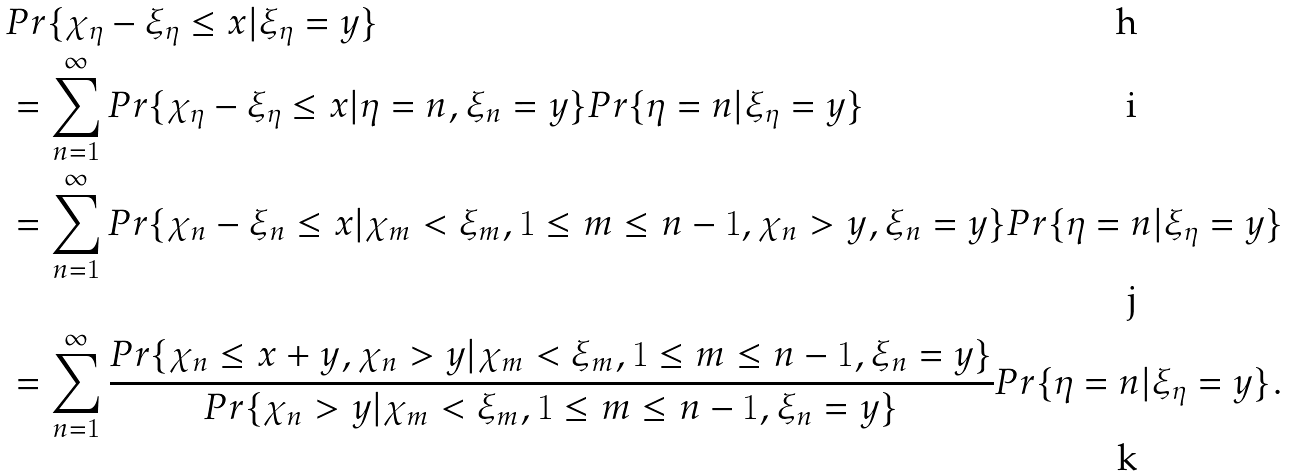<formula> <loc_0><loc_0><loc_500><loc_500>& P r \{ \chi _ { \eta } - \xi _ { \eta } \leq x | \xi _ { \eta } = y \} \\ & = \sum _ { n = 1 } ^ { \infty } P r \{ \chi _ { \eta } - \xi _ { \eta } \leq x | \eta = n , \xi _ { n } = y \} P r \{ \eta = n | \xi _ { \eta } = y \} \\ & = \sum _ { n = 1 } ^ { \infty } P r \{ \chi _ { n } - \xi _ { n } \leq x | \chi _ { m } < \xi _ { m } , 1 \leq m \leq n - 1 , \chi _ { n } > y , \xi _ { n } = y \} P r \{ \eta = n | \xi _ { \eta } = y \} \\ & = \sum _ { n = 1 } ^ { \infty } \frac { P r \{ \chi _ { n } \leq x + y , \chi _ { n } > y | \chi _ { m } < \xi _ { m } , 1 \leq m \leq n - 1 , \xi _ { n } = y \} } { P r \{ \chi _ { n } > y | \chi _ { m } < \xi _ { m } , 1 \leq m \leq n - 1 , \xi _ { n } = y \} } P r \{ \eta = n | \xi _ { \eta } = y \} .</formula> 